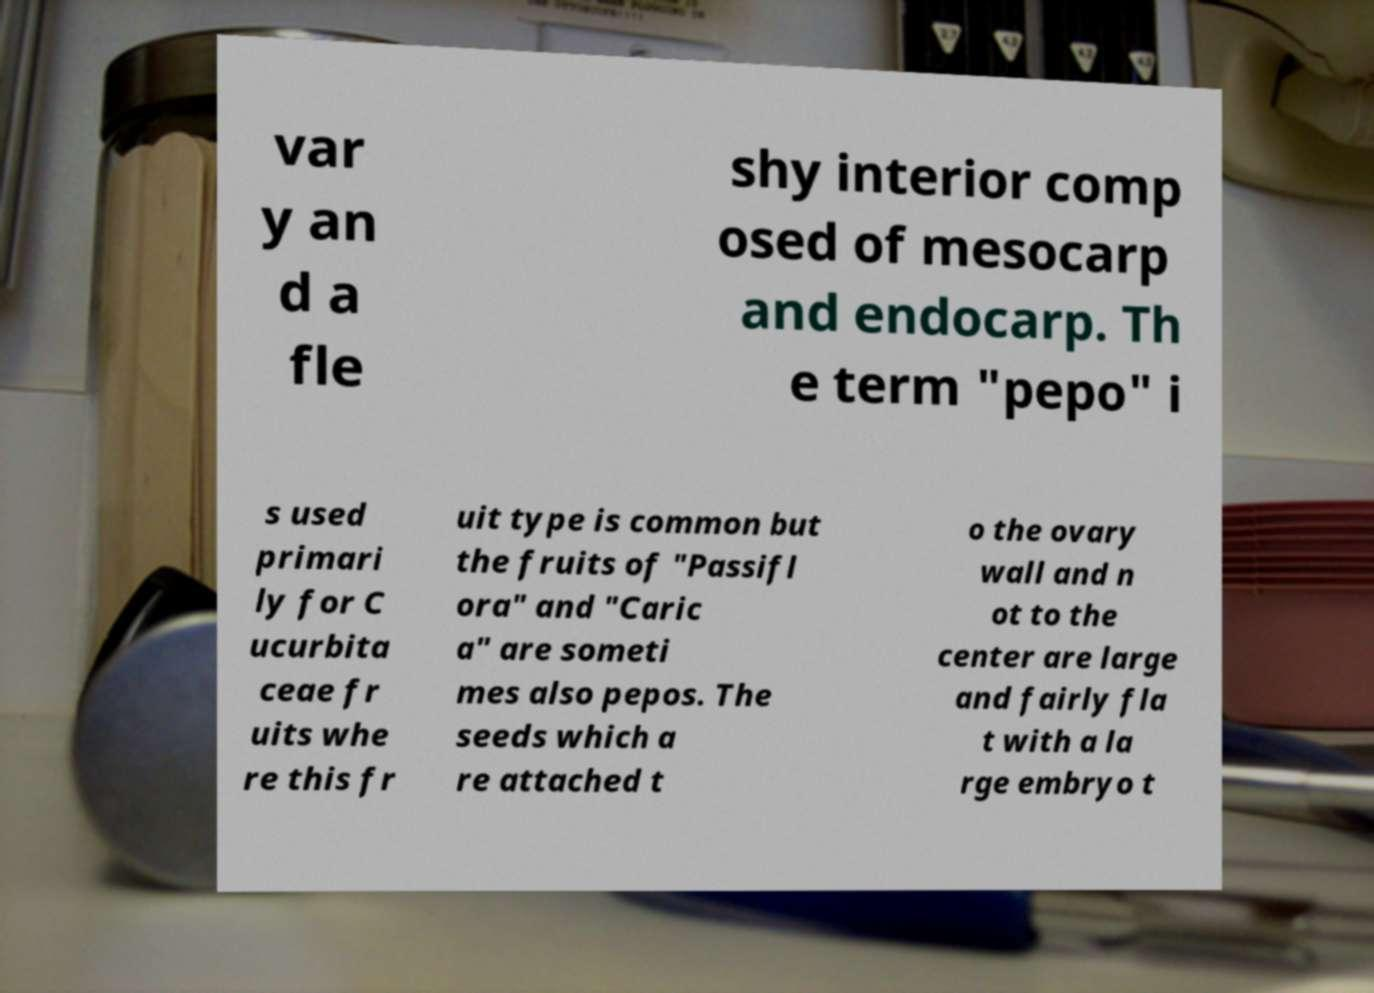Please read and relay the text visible in this image. What does it say? var y an d a fle shy interior comp osed of mesocarp and endocarp. Th e term "pepo" i s used primari ly for C ucurbita ceae fr uits whe re this fr uit type is common but the fruits of "Passifl ora" and "Caric a" are someti mes also pepos. The seeds which a re attached t o the ovary wall and n ot to the center are large and fairly fla t with a la rge embryo t 